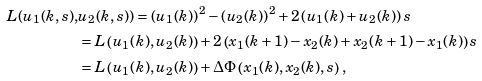<formula> <loc_0><loc_0><loc_500><loc_500>L ( u _ { 1 } ( k , s ) , & u _ { 2 } ( k , s ) ) = \left ( u _ { 1 } ( k ) \right ) ^ { 2 } - \left ( u _ { 2 } ( k ) \right ) ^ { 2 } + 2 \left ( u _ { 1 } ( k ) + u _ { 2 } ( k ) \right ) s \\ & = L \left ( u _ { 1 } ( k ) , u _ { 2 } ( k ) \right ) + 2 \left ( x _ { 1 } ( k + 1 ) - x _ { 2 } ( k ) + x _ { 2 } ( k + 1 ) - x _ { 1 } ( k ) \right ) s \\ & = L \left ( u _ { 1 } ( k ) , u _ { 2 } ( k ) \right ) + \Delta \Phi \left ( x _ { 1 } ( k ) , x _ { 2 } ( k ) , s \right ) \, ,</formula> 